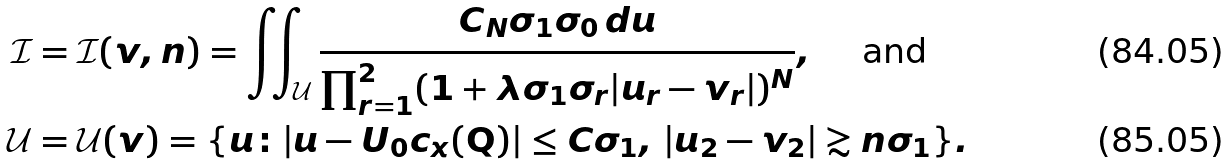Convert formula to latex. <formula><loc_0><loc_0><loc_500><loc_500>\mathcal { I } & = \mathcal { I } ( v , n ) = \iint _ { \mathcal { U } } \frac { C _ { N } \sigma _ { 1 } \sigma _ { 0 } \, d u } { \prod _ { r = 1 } ^ { 2 } ( 1 + \lambda \sigma _ { 1 } \sigma _ { r } | u _ { r } - v _ { r } | ) ^ { N } } , \quad \text { and } \\ \mathcal { U } & = \mathcal { U } ( v ) = \{ u \colon | u - U _ { 0 } c _ { x } ( \mathbf Q ) | \leq C \sigma _ { 1 } , \, | u _ { 2 } - v _ { 2 } | \gtrsim n \sigma _ { 1 } \} .</formula> 